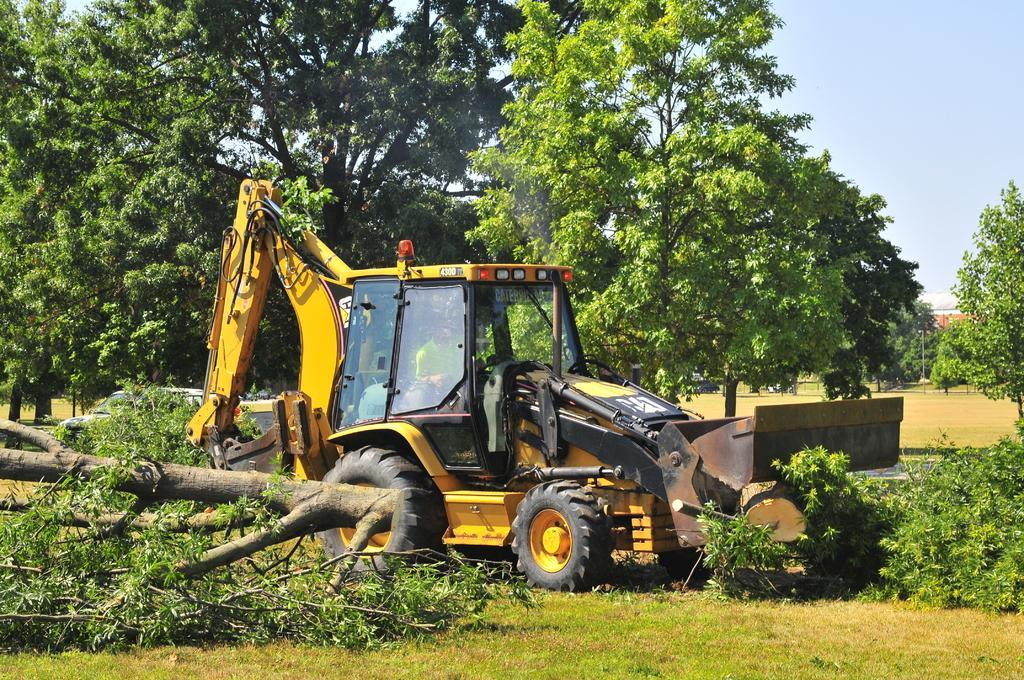How would you summarize this image in a sentence or two? In this image I can see a vehicle which is yellow and black in color on the ground and I can see few wooden logs on the ground and some grass. In the background I can see few trees, the ground, few buildings and the sky. 